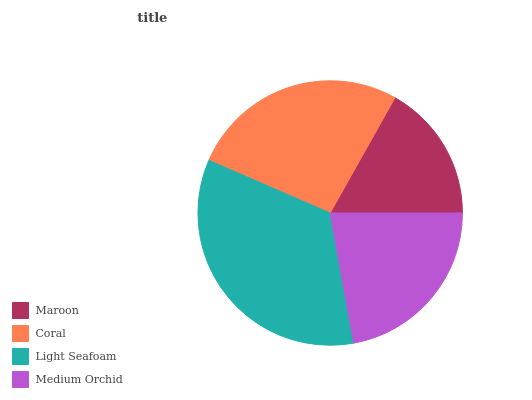Is Maroon the minimum?
Answer yes or no. Yes. Is Light Seafoam the maximum?
Answer yes or no. Yes. Is Coral the minimum?
Answer yes or no. No. Is Coral the maximum?
Answer yes or no. No. Is Coral greater than Maroon?
Answer yes or no. Yes. Is Maroon less than Coral?
Answer yes or no. Yes. Is Maroon greater than Coral?
Answer yes or no. No. Is Coral less than Maroon?
Answer yes or no. No. Is Coral the high median?
Answer yes or no. Yes. Is Medium Orchid the low median?
Answer yes or no. Yes. Is Maroon the high median?
Answer yes or no. No. Is Maroon the low median?
Answer yes or no. No. 